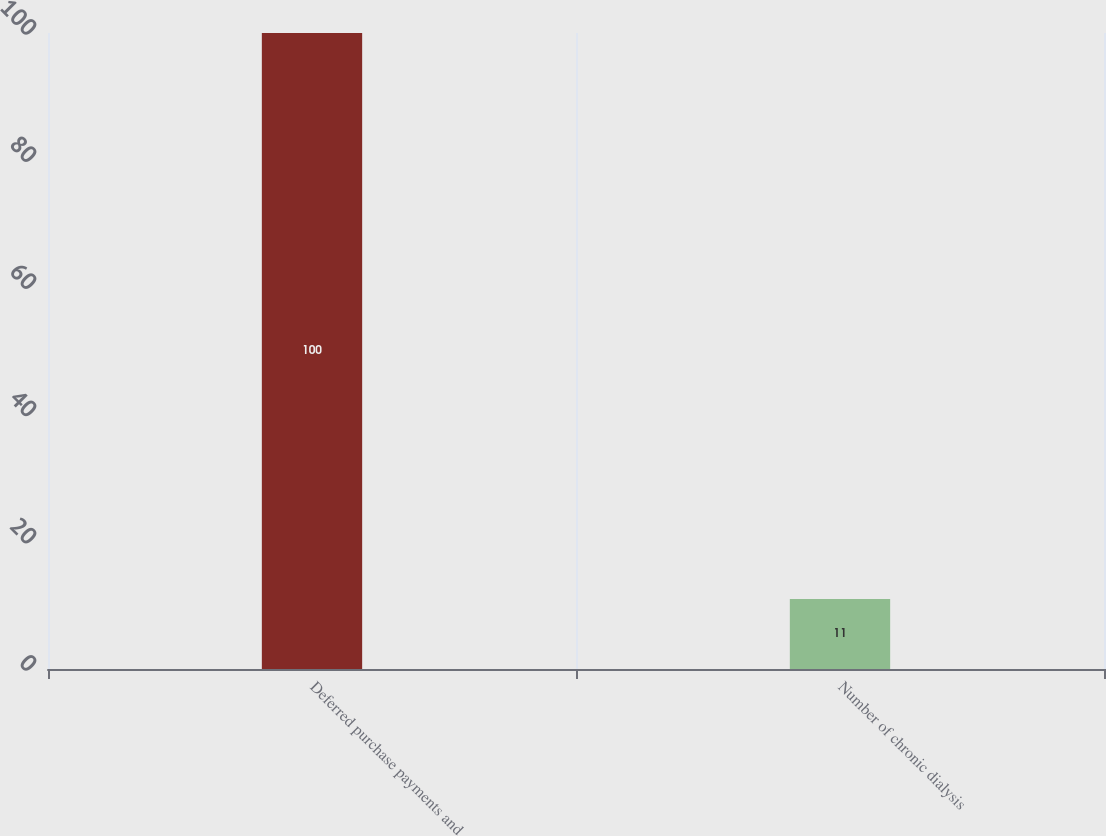<chart> <loc_0><loc_0><loc_500><loc_500><bar_chart><fcel>Deferred purchase payments and<fcel>Number of chronic dialysis<nl><fcel>100<fcel>11<nl></chart> 